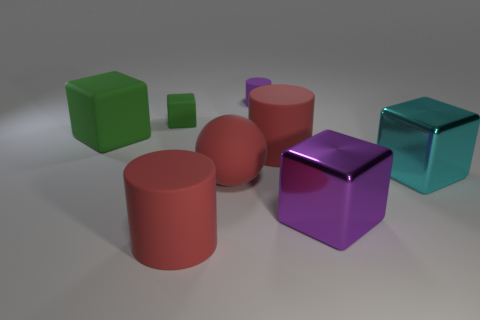Subtract all red rubber cylinders. How many cylinders are left? 1 Subtract all spheres. How many objects are left? 7 Add 2 small red matte blocks. How many objects exist? 10 Subtract all green cubes. How many cubes are left? 2 Subtract 1 cylinders. How many cylinders are left? 2 Add 5 green cubes. How many green cubes exist? 7 Subtract 2 green cubes. How many objects are left? 6 Subtract all blue blocks. Subtract all red balls. How many blocks are left? 4 Subtract all gray blocks. How many green spheres are left? 0 Subtract all cylinders. Subtract all metallic cubes. How many objects are left? 3 